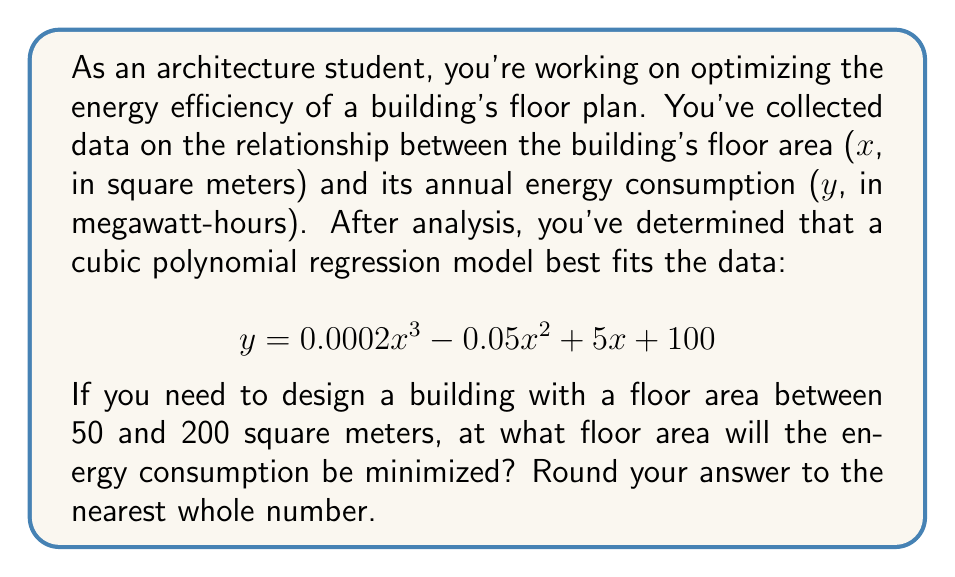Could you help me with this problem? To find the minimum point of the cubic function within the given range, we need to follow these steps:

1. Find the derivative of the function:
   $$\frac{dy}{dx} = 0.0006x^2 - 0.1x + 5$$

2. Set the derivative equal to zero and solve for x:
   $$0.0006x^2 - 0.1x + 5 = 0$$

3. This is a quadratic equation. We can solve it using the quadratic formula:
   $$x = \frac{-b \pm \sqrt{b^2 - 4ac}}{2a}$$
   where $a = 0.0006$, $b = -0.1$, and $c = 5$

4. Plugging in the values:
   $$x = \frac{0.1 \pm \sqrt{(-0.1)^2 - 4(0.0006)(5)}}{2(0.0006)}$$

5. Simplifying:
   $$x = \frac{0.1 \pm \sqrt{0.01 - 0.012}}{0.0012} = \frac{0.1 \pm \sqrt{-0.002}}{0.0012}$$

6. Since the square root of a negative number gives us imaginary solutions, there are no real critical points.

7. This means the minimum must occur at one of the endpoints of our range: 50 or 200.

8. Evaluate the original function at both points:
   At x = 50: $y = 0.0002(50)^3 - 0.05(50)^2 + 5(50) + 100 = 325$
   At x = 200: $y = 0.0002(200)^3 - 0.05(200)^2 + 5(200) + 100 = 2100$

9. The smaller value occurs at x = 50, so this is our minimum point within the given range.
Answer: 50 square meters 